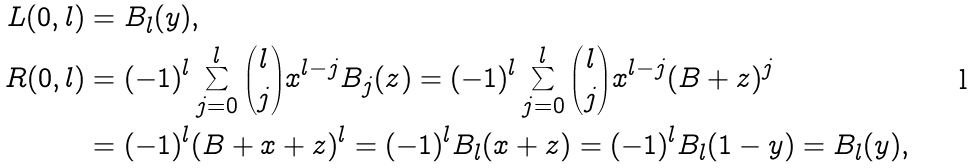Convert formula to latex. <formula><loc_0><loc_0><loc_500><loc_500>L ( 0 , l ) & = B _ { l } ( y ) , \\ R ( 0 , l ) & = ( - 1 ) ^ { l } \sum _ { j = 0 } ^ { l } { l \choose j } x ^ { l - j } B _ { j } ( z ) = ( - 1 ) ^ { l } \sum _ { j = 0 } ^ { l } { l \choose j } x ^ { l - j } ( B + z ) ^ { j } \\ & = ( - 1 ) ^ { l } ( B + x + z ) ^ { l } = ( - 1 ) ^ { l } B _ { l } ( x + z ) = ( - 1 ) ^ { l } B _ { l } ( 1 - y ) = B _ { l } ( y ) ,</formula> 